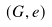<formula> <loc_0><loc_0><loc_500><loc_500>( G , e )</formula> 